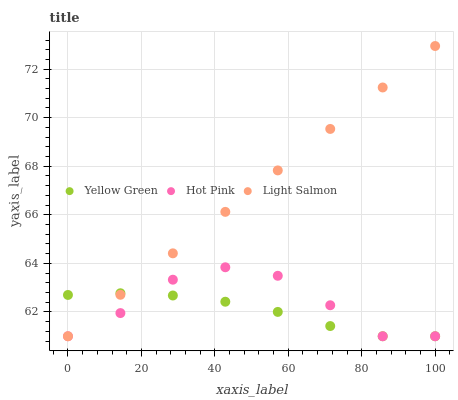Does Yellow Green have the minimum area under the curve?
Answer yes or no. Yes. Does Light Salmon have the maximum area under the curve?
Answer yes or no. Yes. Does Hot Pink have the minimum area under the curve?
Answer yes or no. No. Does Hot Pink have the maximum area under the curve?
Answer yes or no. No. Is Light Salmon the smoothest?
Answer yes or no. Yes. Is Hot Pink the roughest?
Answer yes or no. Yes. Is Yellow Green the smoothest?
Answer yes or no. No. Is Yellow Green the roughest?
Answer yes or no. No. Does Light Salmon have the lowest value?
Answer yes or no. Yes. Does Light Salmon have the highest value?
Answer yes or no. Yes. Does Hot Pink have the highest value?
Answer yes or no. No. Does Hot Pink intersect Light Salmon?
Answer yes or no. Yes. Is Hot Pink less than Light Salmon?
Answer yes or no. No. Is Hot Pink greater than Light Salmon?
Answer yes or no. No. 